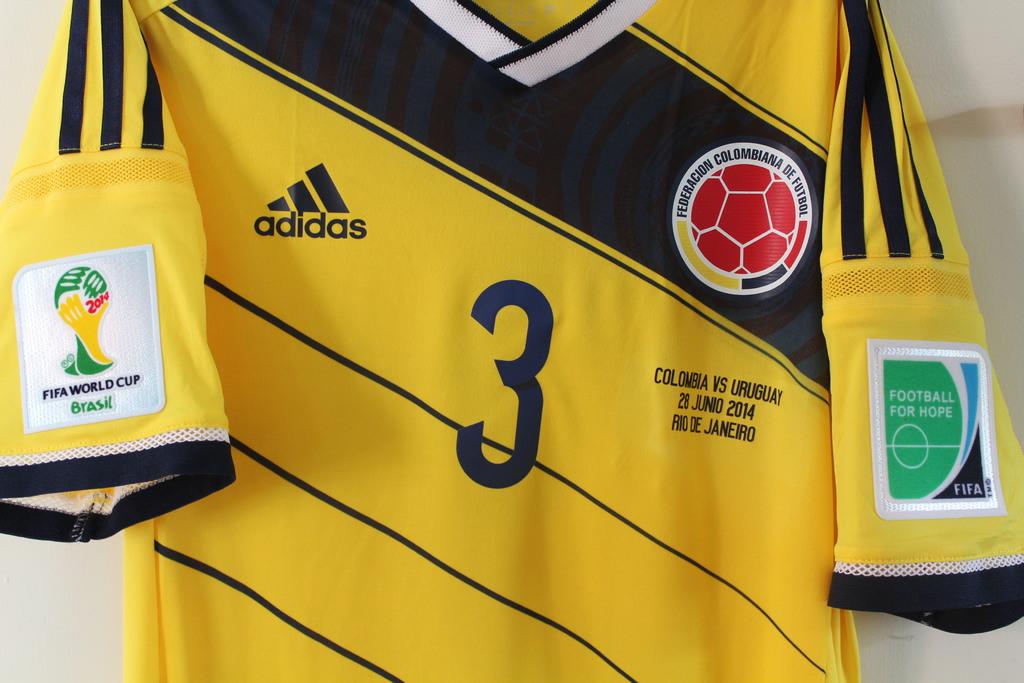What brand of clothing is this shirt?
Give a very brief answer. Adidas. What is this player's number?
Keep it short and to the point. 3. 